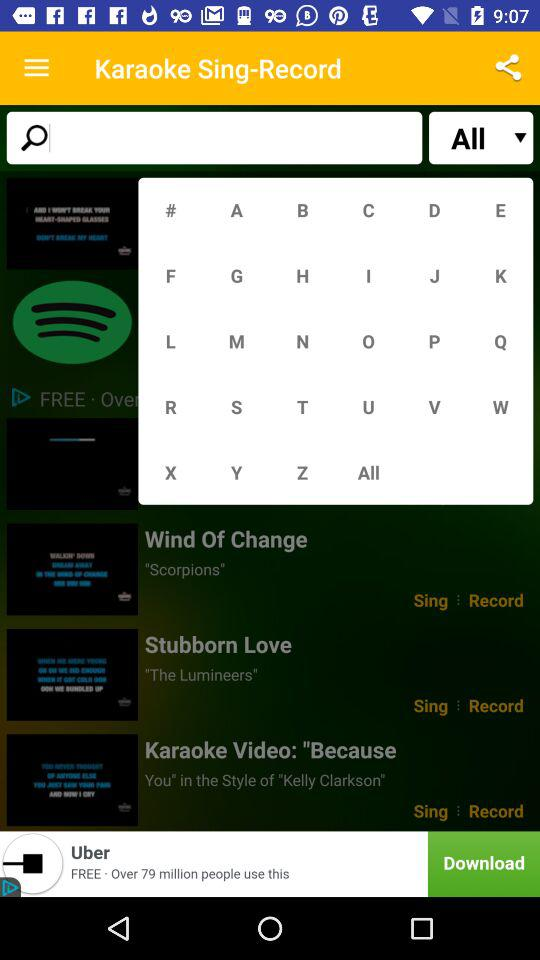What is selected in the drop down list?
When the provided information is insufficient, respond with <no answer>. <no answer> 